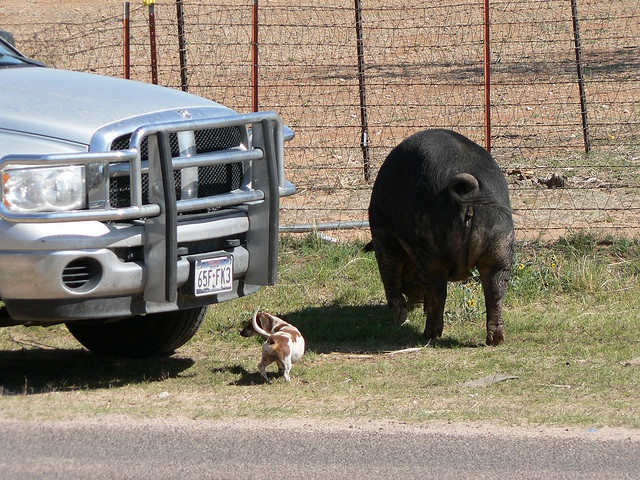Describe the objects in this image and their specific colors. I can see truck in tan, black, gray, lightgray, and darkgray tones and dog in tan, ivory, black, and gray tones in this image. 